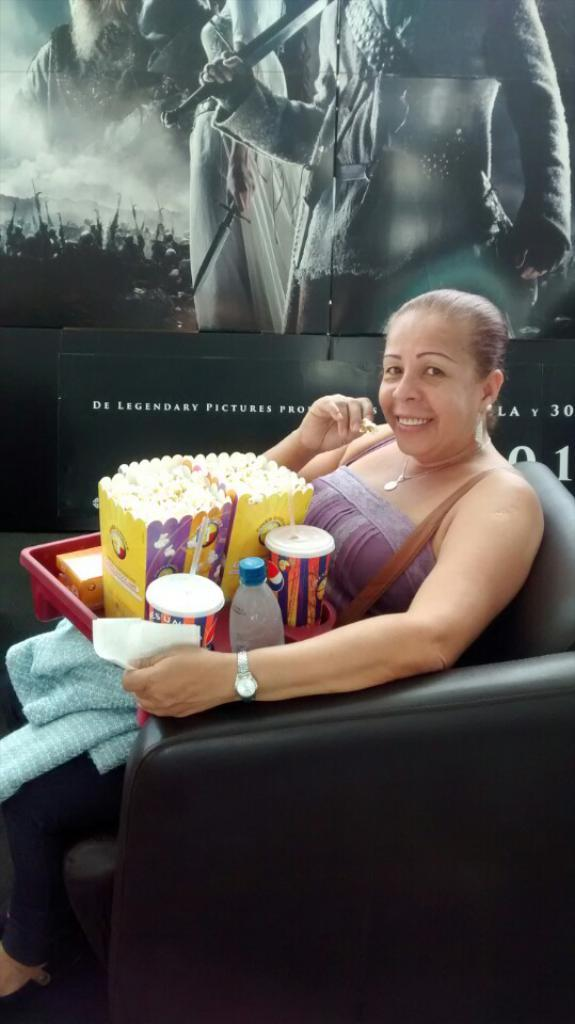What is the lady in the image doing? The lady is sitting on the couch in the image. What is on the tray in the image? There are food items on a tray in the image. What can be seen on the wall in the image? There is a poster with images and text in the image. How many cakes are being served by the police in the image? There are no cakes or police present in the image. Is there a note attached to the poster in the image? The provided facts do not mention a note, so we cannot determine if there is a note attached to the poster in the image. 